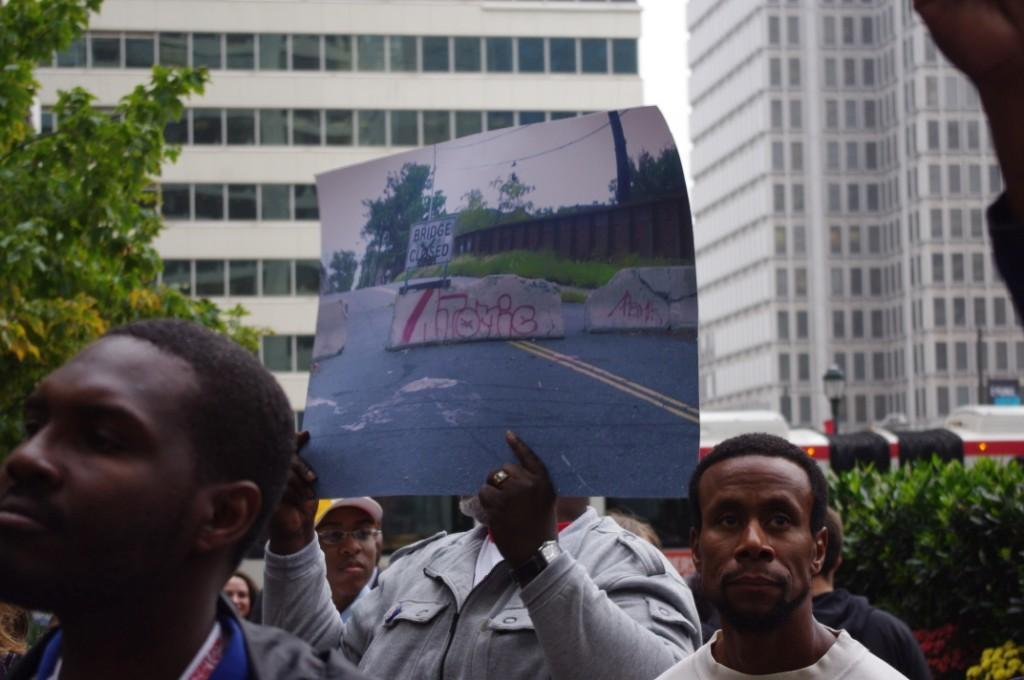What are the people in the image doing? The people in the image are standing. Can you describe what one of the people is holding? One of the people is holding a poster. What can be seen in the background of the image? There are trees and buildings visible in the background. What else is present in the image? There is a vehicle in the image. What color is the crayon being used by the person holding the poster in the image? There is no crayon present in the image. How many trays can be seen on the table in the image? There is no table or tray present in the image. 